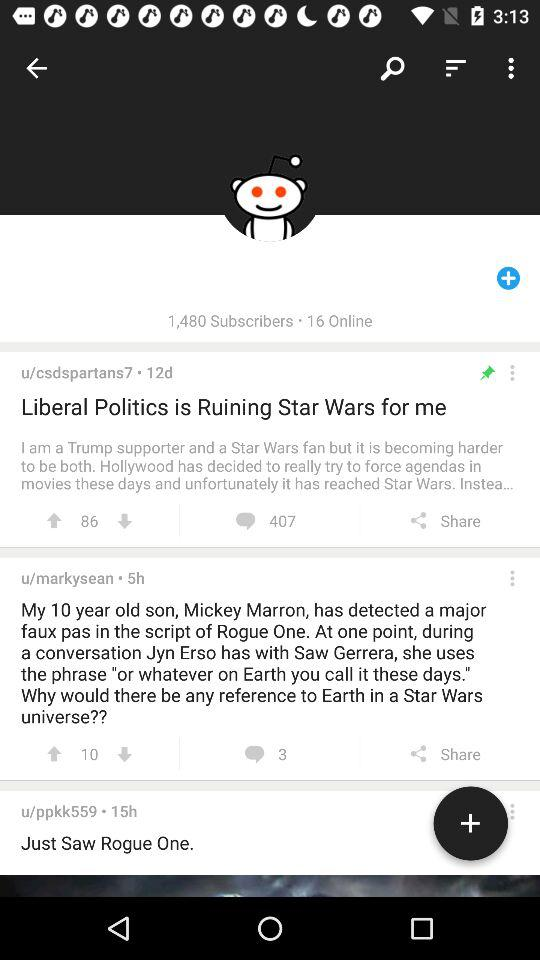How many users have commented on the post?
Answer the question using a single word or phrase. 3 